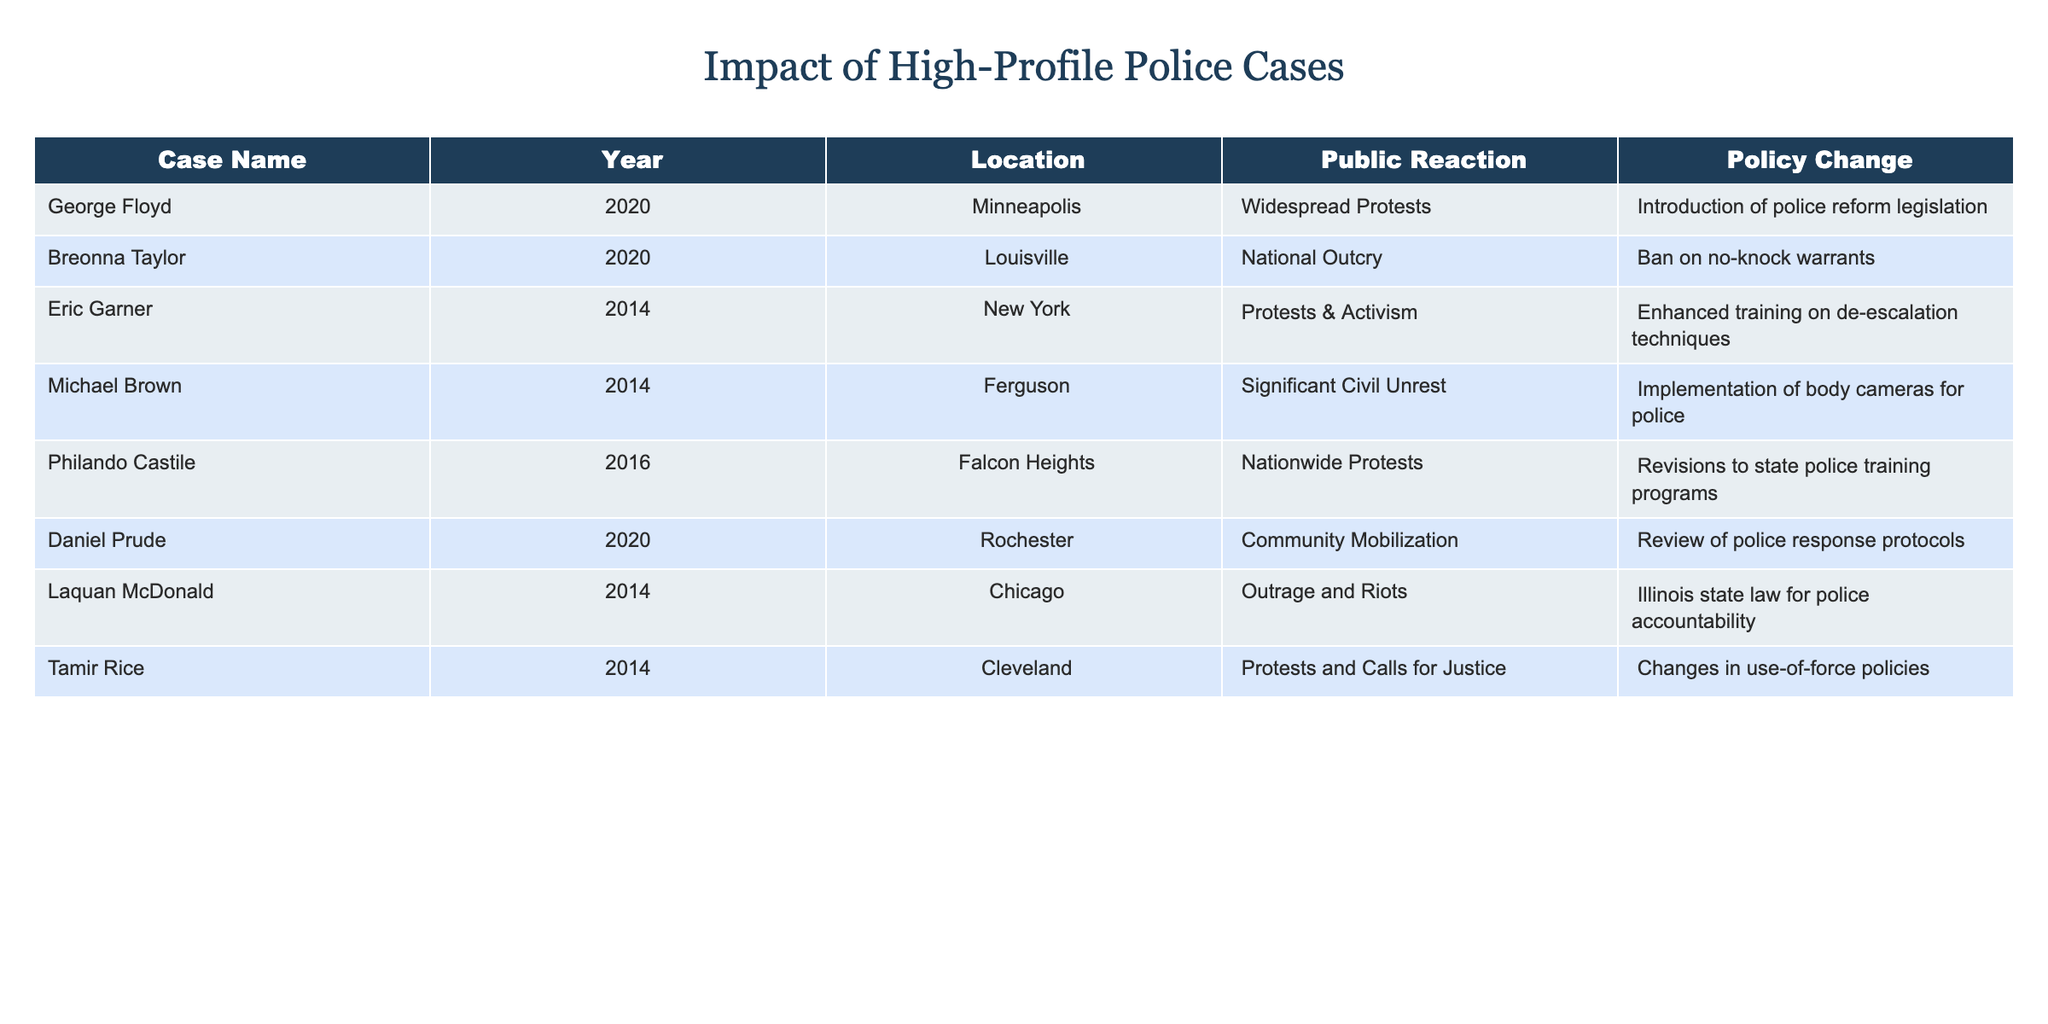What was the public reaction to the George Floyd case? The table directly states the public reaction for each case. For George Floyd, the public reaction listed is "Widespread Protests."
Answer: Widespread Protests Which case resulted in a policy change regarding no-knock warrants? By scanning the table for the policy changes, it indicates that the Breonna Taylor case led to a "Ban on no-knock warrants."
Answer: Ban on no-knock warrants How many cases resulted in some form of police reform? To find this, count all cases with associated policy changes indicating reform. The cases with reforms are: George Floyd, Breonna Taylor, Eric Garner, Michael Brown, Philando Castile, Laquan McDonald, Tamir Rice. This totals to 7 cases.
Answer: 7 Did the Eric Garner case lead to changes in use-of-force policies? By checking the table under the Eric Garner row, the policy change listed is "Enhanced training on de-escalation techniques," not directly related to use-of-force policies.
Answer: No Which city's case caused nationwide protests and led to revisions in police training programs? The case that led to nationwide protests and is linked to revisions in state police training programs is the Philando Castile case in Falcon Heights.
Answer: Falcon Heights What percentage of the cases resulted in the introduction of new legislation or laws? There are 8 total cases. The cases resulting in new legislation or laws are George Floyd, Breonna Taylor, and Laquan McDonald, totaling 3. The percentage is (3/8)*100 = 37.5%.
Answer: 37.5% Which years had the most cases listed in the table? By looking through the years in the tabulated data, 2020 appears 3 times (George Floyd, Breonna Taylor, Daniel Prude), while 2014 appears 4 times (Eric Garner, Michael Brown, Tamir Rice, Laquan McDonald). The year with the most cases is 2014.
Answer: 2014 Which location had the case that led to the review of police response protocols? The location for the case that led to the review of police response protocols is Rochester, associated with the Daniel Prude case.
Answer: Rochester 